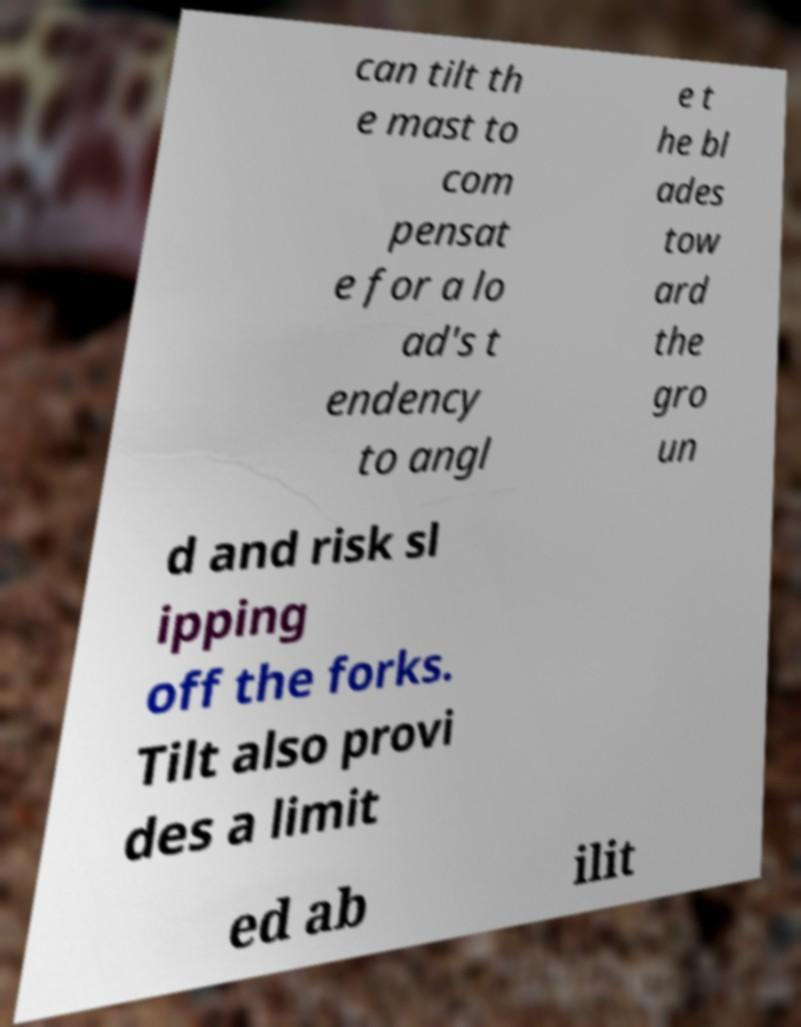Could you extract and type out the text from this image? can tilt th e mast to com pensat e for a lo ad's t endency to angl e t he bl ades tow ard the gro un d and risk sl ipping off the forks. Tilt also provi des a limit ed ab ilit 